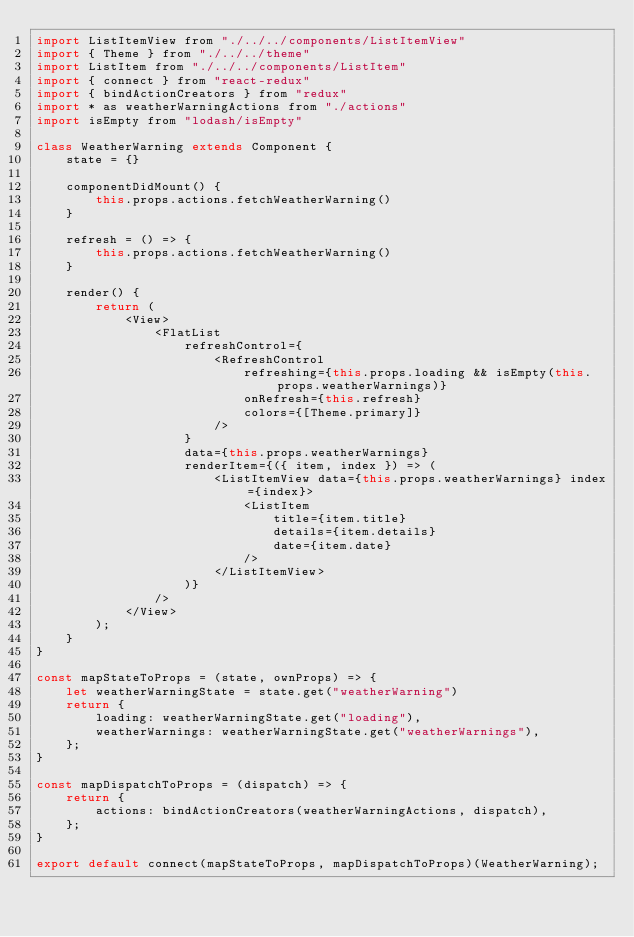Convert code to text. <code><loc_0><loc_0><loc_500><loc_500><_JavaScript_>import ListItemView from "./../../components/ListItemView"
import { Theme } from "./../../theme"
import ListItem from "./../../components/ListItem"
import { connect } from "react-redux"
import { bindActionCreators } from "redux"
import * as weatherWarningActions from "./actions"
import isEmpty from "lodash/isEmpty"

class WeatherWarning extends Component {
    state = {}

    componentDidMount() {
        this.props.actions.fetchWeatherWarning()
    }

    refresh = () => {
        this.props.actions.fetchWeatherWarning()
    }

    render() {
        return (
            <View>
                <FlatList
                    refreshControl={
                        <RefreshControl
                            refreshing={this.props.loading && isEmpty(this.props.weatherWarnings)}
                            onRefresh={this.refresh}
                            colors={[Theme.primary]}
                        />
                    }
                    data={this.props.weatherWarnings}
                    renderItem={({ item, index }) => (
                        <ListItemView data={this.props.weatherWarnings} index={index}>
                            <ListItem
                                title={item.title}
                                details={item.details}
                                date={item.date}
                            />
                        </ListItemView>
                    )}
                />
            </View>
        );
    }
}

const mapStateToProps = (state, ownProps) => {
    let weatherWarningState = state.get("weatherWarning")
    return {
        loading: weatherWarningState.get("loading"),
        weatherWarnings: weatherWarningState.get("weatherWarnings"),
    };
}

const mapDispatchToProps = (dispatch) => {
    return {
        actions: bindActionCreators(weatherWarningActions, dispatch),
    };
}

export default connect(mapStateToProps, mapDispatchToProps)(WeatherWarning);</code> 